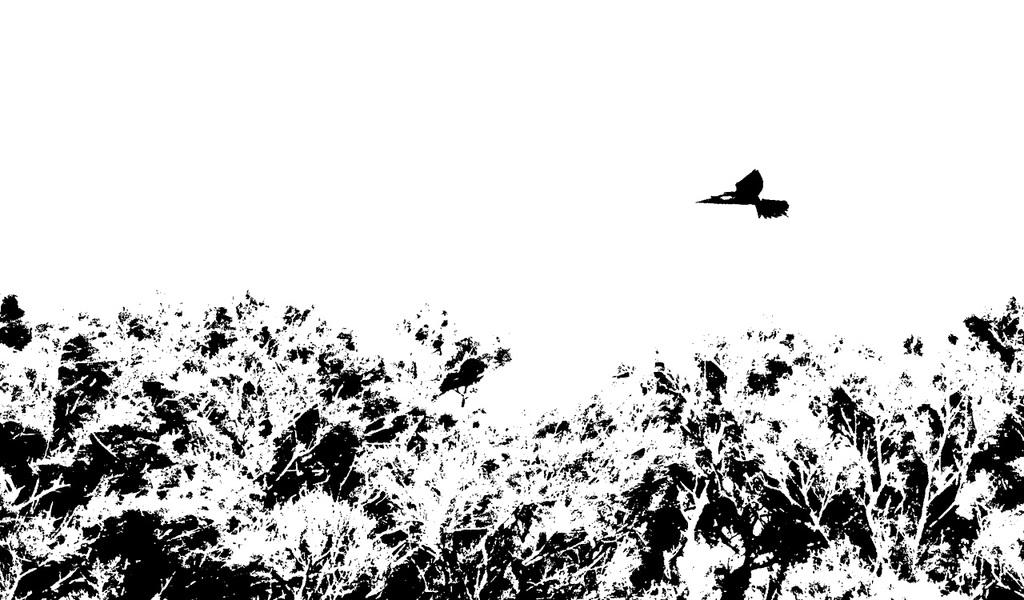What type of vegetation is at the bottom of the image? There are trees at the bottom of the image. What is happening in the center of the image? There is a bird flying in the center of the image. What type of veil is being used by the bird in the image? There is no veil present in the image; it features a bird flying. How does the bird use the brake while flying in the image? Birds do not have brakes, as they are not mechanical objects. The bird in the image is flying naturally. 